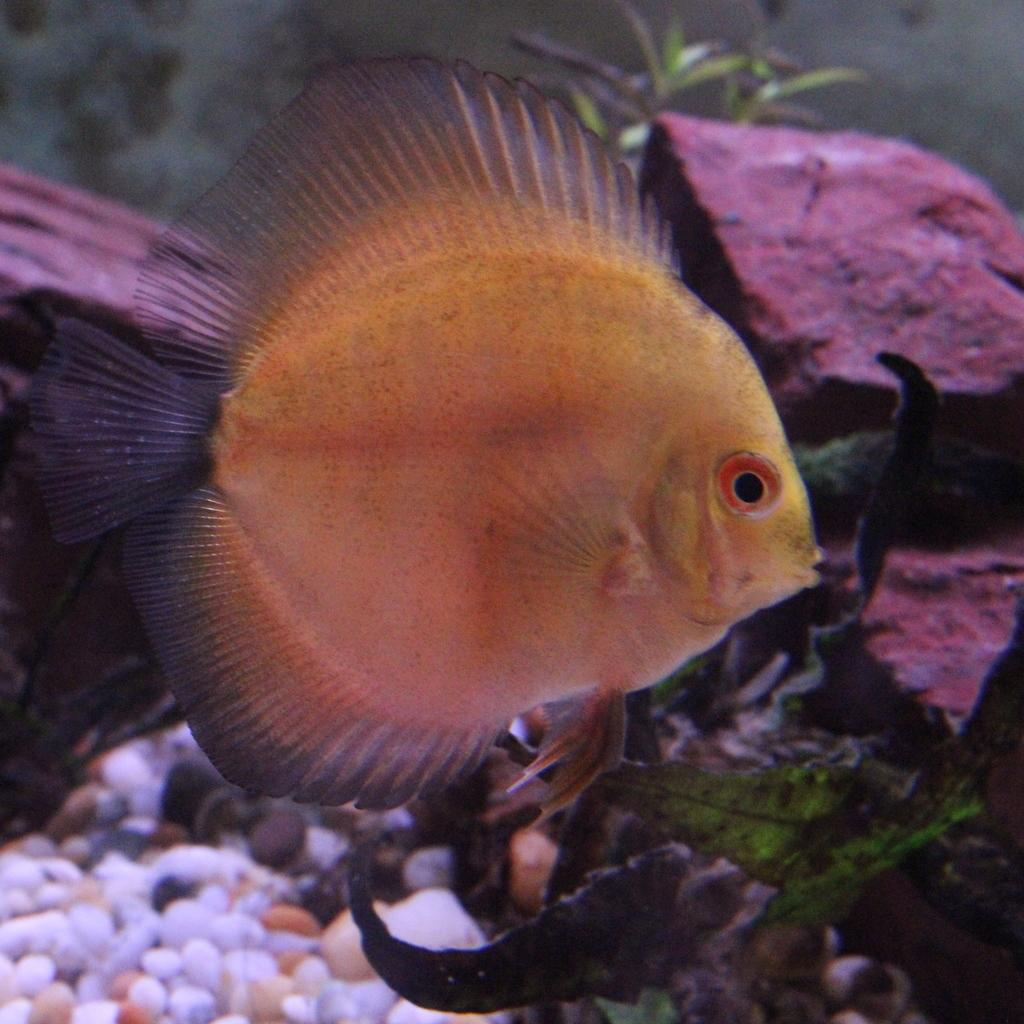What type of animal is present in the image? There is a fish in the image. What other objects can be seen in the image? There are stones and leaves in the image. Where are the elements located in the image? The elements are in the water. What is the reason for the surprise in the middle of the image? There is no surprise present in the image, as it only contains a fish, stones, leaves, and water. 